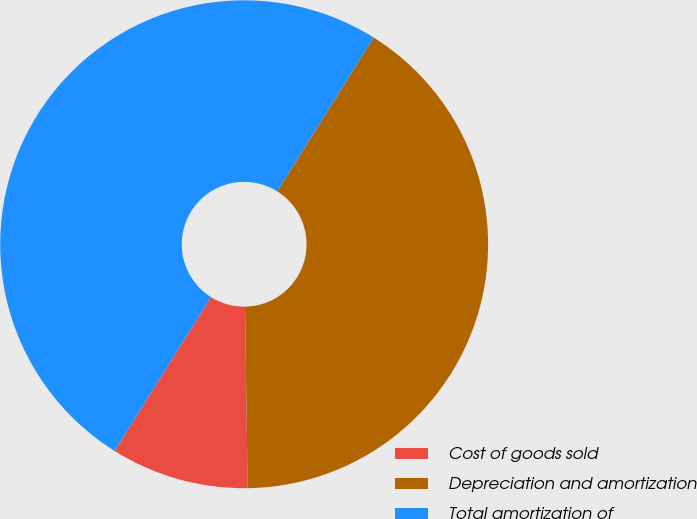Convert chart. <chart><loc_0><loc_0><loc_500><loc_500><pie_chart><fcel>Cost of goods sold<fcel>Depreciation and amortization<fcel>Total amortization of<nl><fcel>9.14%<fcel>40.86%<fcel>50.0%<nl></chart> 